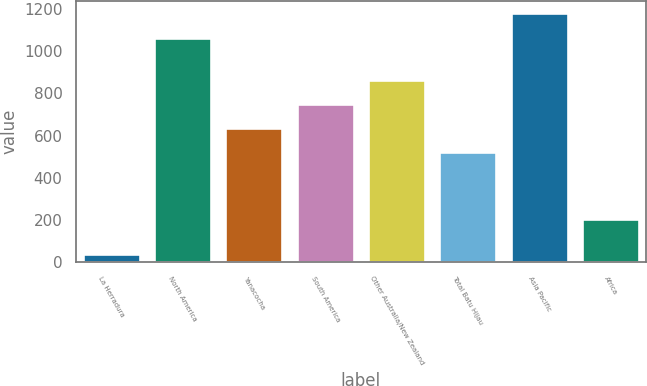<chart> <loc_0><loc_0><loc_500><loc_500><bar_chart><fcel>La Herradura<fcel>North America<fcel>Yanacocha<fcel>South America<fcel>Other Australia/New Zealand<fcel>Total Batu Hijau<fcel>Asia Pacific<fcel>Africa<nl><fcel>38<fcel>1060<fcel>637<fcel>751<fcel>865<fcel>523<fcel>1178<fcel>205<nl></chart> 